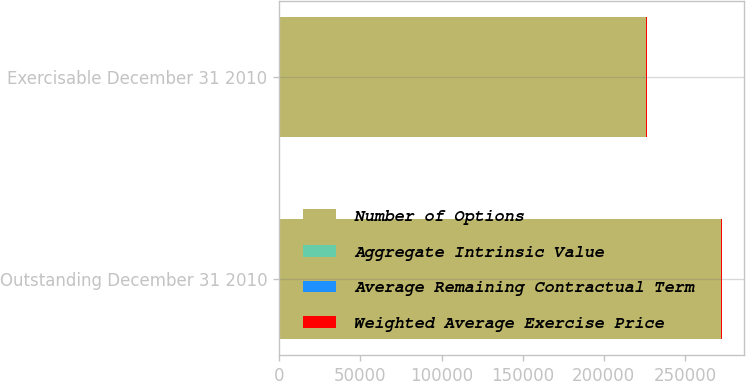Convert chart. <chart><loc_0><loc_0><loc_500><loc_500><stacked_bar_chart><ecel><fcel>Outstanding December 31 2010<fcel>Exercisable December 31 2010<nl><fcel>Number of Options<fcel>272241<fcel>226231<nl><fcel>Aggregate Intrinsic Value<fcel>42.26<fcel>44.56<nl><fcel>Average Remaining Contractual Term<fcel>4.47<fcel>3.83<nl><fcel>Weighted Average Exercise Price<fcel>771<fcel>469<nl></chart> 